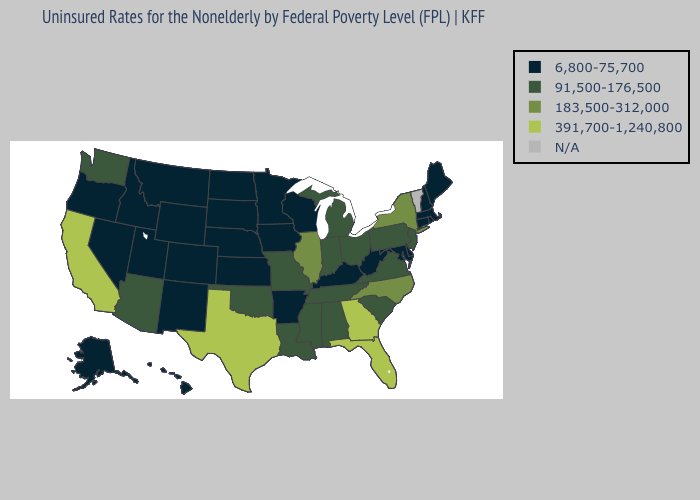What is the value of Oklahoma?
Answer briefly. 91,500-176,500. Does Illinois have the lowest value in the MidWest?
Write a very short answer. No. Name the states that have a value in the range N/A?
Be succinct. Vermont. Name the states that have a value in the range N/A?
Write a very short answer. Vermont. What is the highest value in states that border Kentucky?
Give a very brief answer. 183,500-312,000. What is the value of Michigan?
Be succinct. 91,500-176,500. Name the states that have a value in the range 183,500-312,000?
Quick response, please. Illinois, New York, North Carolina. Name the states that have a value in the range 183,500-312,000?
Short answer required. Illinois, New York, North Carolina. Which states have the lowest value in the South?
Be succinct. Arkansas, Delaware, Kentucky, Maryland, West Virginia. Which states have the lowest value in the USA?
Write a very short answer. Alaska, Arkansas, Colorado, Connecticut, Delaware, Hawaii, Idaho, Iowa, Kansas, Kentucky, Maine, Maryland, Massachusetts, Minnesota, Montana, Nebraska, Nevada, New Hampshire, New Mexico, North Dakota, Oregon, Rhode Island, South Dakota, Utah, West Virginia, Wisconsin, Wyoming. Does Maine have the highest value in the Northeast?
Answer briefly. No. What is the lowest value in the South?
Short answer required. 6,800-75,700. Among the states that border Oklahoma , does Texas have the highest value?
Be succinct. Yes. What is the value of Wisconsin?
Short answer required. 6,800-75,700. 